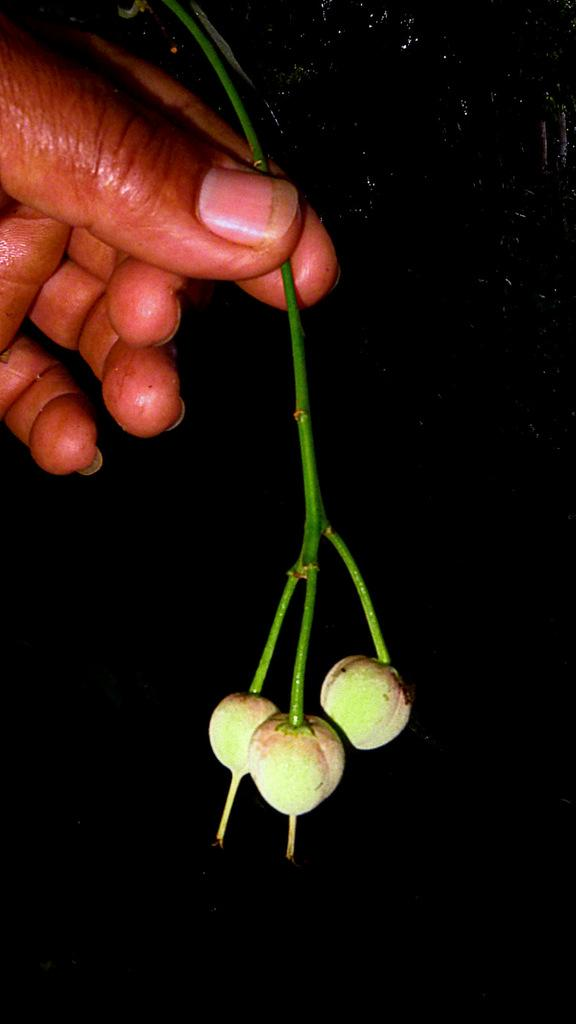What is the person in the image holding? The person is holding a stem in the image. What else can be seen in the image besides the person? There are fruits in the image. What can be observed about the background of the image? The background of the image is dark. What type of suit is the person wearing in the image? There is no suit visible in the image; the person is holding a stem and there are fruits present. 